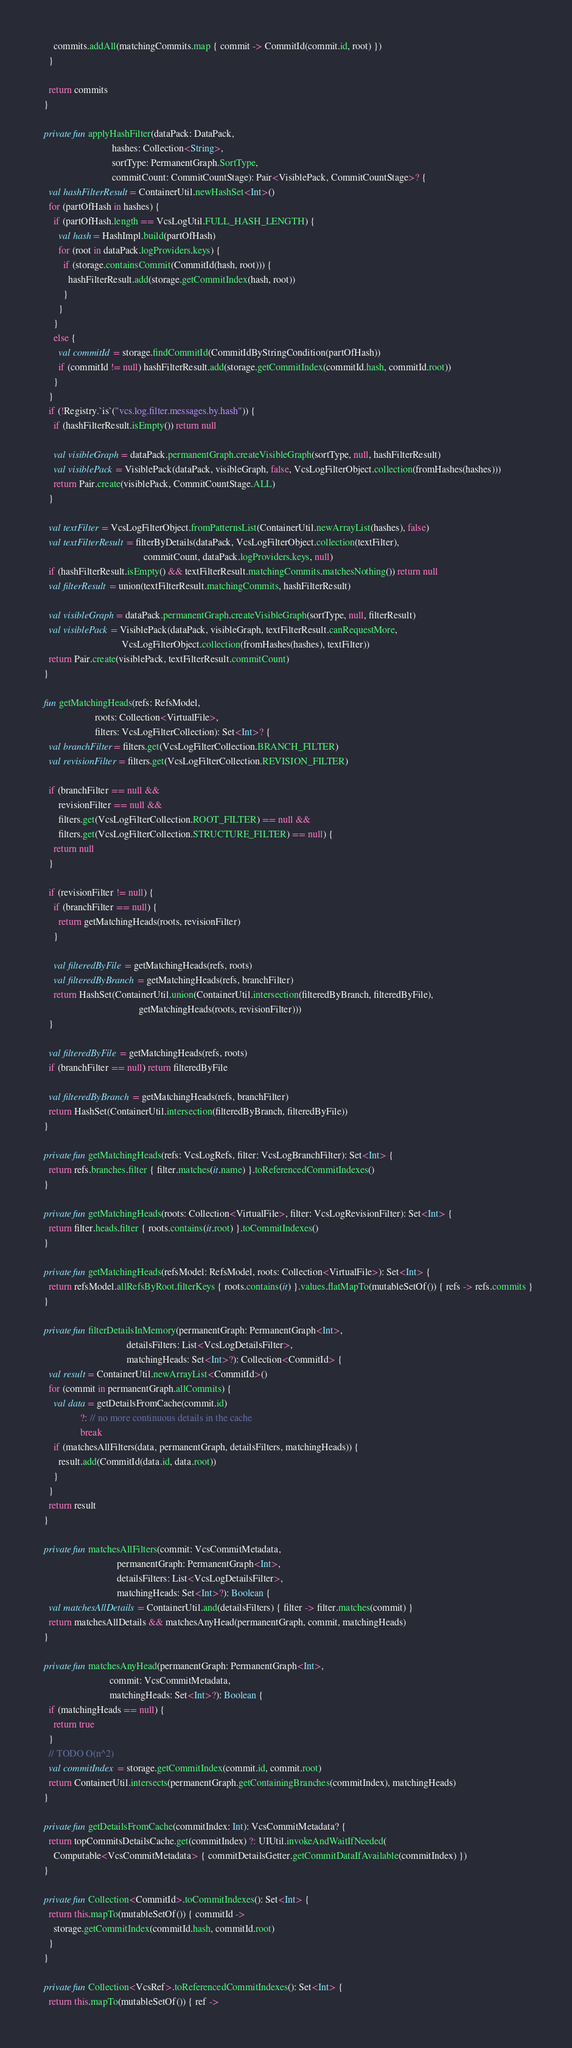Convert code to text. <code><loc_0><loc_0><loc_500><loc_500><_Kotlin_>      commits.addAll(matchingCommits.map { commit -> CommitId(commit.id, root) })
    }

    return commits
  }

  private fun applyHashFilter(dataPack: DataPack,
                              hashes: Collection<String>,
                              sortType: PermanentGraph.SortType,
                              commitCount: CommitCountStage): Pair<VisiblePack, CommitCountStage>? {
    val hashFilterResult = ContainerUtil.newHashSet<Int>()
    for (partOfHash in hashes) {
      if (partOfHash.length == VcsLogUtil.FULL_HASH_LENGTH) {
        val hash = HashImpl.build(partOfHash)
        for (root in dataPack.logProviders.keys) {
          if (storage.containsCommit(CommitId(hash, root))) {
            hashFilterResult.add(storage.getCommitIndex(hash, root))
          }
        }
      }
      else {
        val commitId = storage.findCommitId(CommitIdByStringCondition(partOfHash))
        if (commitId != null) hashFilterResult.add(storage.getCommitIndex(commitId.hash, commitId.root))
      }
    }
    if (!Registry.`is`("vcs.log.filter.messages.by.hash")) {
      if (hashFilterResult.isEmpty()) return null

      val visibleGraph = dataPack.permanentGraph.createVisibleGraph(sortType, null, hashFilterResult)
      val visiblePack = VisiblePack(dataPack, visibleGraph, false, VcsLogFilterObject.collection(fromHashes(hashes)))
      return Pair.create(visiblePack, CommitCountStage.ALL)
    }

    val textFilter = VcsLogFilterObject.fromPatternsList(ContainerUtil.newArrayList(hashes), false)
    val textFilterResult = filterByDetails(dataPack, VcsLogFilterObject.collection(textFilter),
                                           commitCount, dataPack.logProviders.keys, null)
    if (hashFilterResult.isEmpty() && textFilterResult.matchingCommits.matchesNothing()) return null
    val filterResult = union(textFilterResult.matchingCommits, hashFilterResult)

    val visibleGraph = dataPack.permanentGraph.createVisibleGraph(sortType, null, filterResult)
    val visiblePack = VisiblePack(dataPack, visibleGraph, textFilterResult.canRequestMore,
                                  VcsLogFilterObject.collection(fromHashes(hashes), textFilter))
    return Pair.create(visiblePack, textFilterResult.commitCount)
  }

  fun getMatchingHeads(refs: RefsModel,
                       roots: Collection<VirtualFile>,
                       filters: VcsLogFilterCollection): Set<Int>? {
    val branchFilter = filters.get(VcsLogFilterCollection.BRANCH_FILTER)
    val revisionFilter = filters.get(VcsLogFilterCollection.REVISION_FILTER)

    if (branchFilter == null &&
        revisionFilter == null &&
        filters.get(VcsLogFilterCollection.ROOT_FILTER) == null &&
        filters.get(VcsLogFilterCollection.STRUCTURE_FILTER) == null) {
      return null
    }

    if (revisionFilter != null) {
      if (branchFilter == null) {
        return getMatchingHeads(roots, revisionFilter)
      }

      val filteredByFile = getMatchingHeads(refs, roots)
      val filteredByBranch = getMatchingHeads(refs, branchFilter)
      return HashSet(ContainerUtil.union(ContainerUtil.intersection(filteredByBranch, filteredByFile),
                                         getMatchingHeads(roots, revisionFilter)))
    }

    val filteredByFile = getMatchingHeads(refs, roots)
    if (branchFilter == null) return filteredByFile

    val filteredByBranch = getMatchingHeads(refs, branchFilter)
    return HashSet(ContainerUtil.intersection(filteredByBranch, filteredByFile))
  }

  private fun getMatchingHeads(refs: VcsLogRefs, filter: VcsLogBranchFilter): Set<Int> {
    return refs.branches.filter { filter.matches(it.name) }.toReferencedCommitIndexes()
  }

  private fun getMatchingHeads(roots: Collection<VirtualFile>, filter: VcsLogRevisionFilter): Set<Int> {
    return filter.heads.filter { roots.contains(it.root) }.toCommitIndexes()
  }

  private fun getMatchingHeads(refsModel: RefsModel, roots: Collection<VirtualFile>): Set<Int> {
    return refsModel.allRefsByRoot.filterKeys { roots.contains(it) }.values.flatMapTo(mutableSetOf()) { refs -> refs.commits }
  }

  private fun filterDetailsInMemory(permanentGraph: PermanentGraph<Int>,
                                    detailsFilters: List<VcsLogDetailsFilter>,
                                    matchingHeads: Set<Int>?): Collection<CommitId> {
    val result = ContainerUtil.newArrayList<CommitId>()
    for (commit in permanentGraph.allCommits) {
      val data = getDetailsFromCache(commit.id)
                 ?: // no more continuous details in the cache
                 break
      if (matchesAllFilters(data, permanentGraph, detailsFilters, matchingHeads)) {
        result.add(CommitId(data.id, data.root))
      }
    }
    return result
  }

  private fun matchesAllFilters(commit: VcsCommitMetadata,
                                permanentGraph: PermanentGraph<Int>,
                                detailsFilters: List<VcsLogDetailsFilter>,
                                matchingHeads: Set<Int>?): Boolean {
    val matchesAllDetails = ContainerUtil.and(detailsFilters) { filter -> filter.matches(commit) }
    return matchesAllDetails && matchesAnyHead(permanentGraph, commit, matchingHeads)
  }

  private fun matchesAnyHead(permanentGraph: PermanentGraph<Int>,
                             commit: VcsCommitMetadata,
                             matchingHeads: Set<Int>?): Boolean {
    if (matchingHeads == null) {
      return true
    }
    // TODO O(n^2)
    val commitIndex = storage.getCommitIndex(commit.id, commit.root)
    return ContainerUtil.intersects(permanentGraph.getContainingBranches(commitIndex), matchingHeads)
  }

  private fun getDetailsFromCache(commitIndex: Int): VcsCommitMetadata? {
    return topCommitsDetailsCache.get(commitIndex) ?: UIUtil.invokeAndWaitIfNeeded(
      Computable<VcsCommitMetadata> { commitDetailsGetter.getCommitDataIfAvailable(commitIndex) })
  }

  private fun Collection<CommitId>.toCommitIndexes(): Set<Int> {
    return this.mapTo(mutableSetOf()) { commitId ->
      storage.getCommitIndex(commitId.hash, commitId.root)
    }
  }

  private fun Collection<VcsRef>.toReferencedCommitIndexes(): Set<Int> {
    return this.mapTo(mutableSetOf()) { ref -></code> 